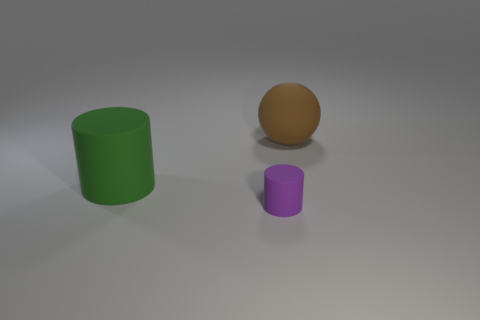Add 3 green things. How many objects exist? 6 Subtract all cylinders. How many objects are left? 1 Subtract 0 gray blocks. How many objects are left? 3 Subtract all yellow things. Subtract all big rubber things. How many objects are left? 1 Add 2 purple matte cylinders. How many purple matte cylinders are left? 3 Add 1 cyan cubes. How many cyan cubes exist? 1 